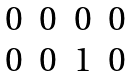Convert formula to latex. <formula><loc_0><loc_0><loc_500><loc_500>\begin{matrix} 0 & 0 & 0 & 0 \\ 0 & 0 & 1 & 0 \end{matrix}</formula> 